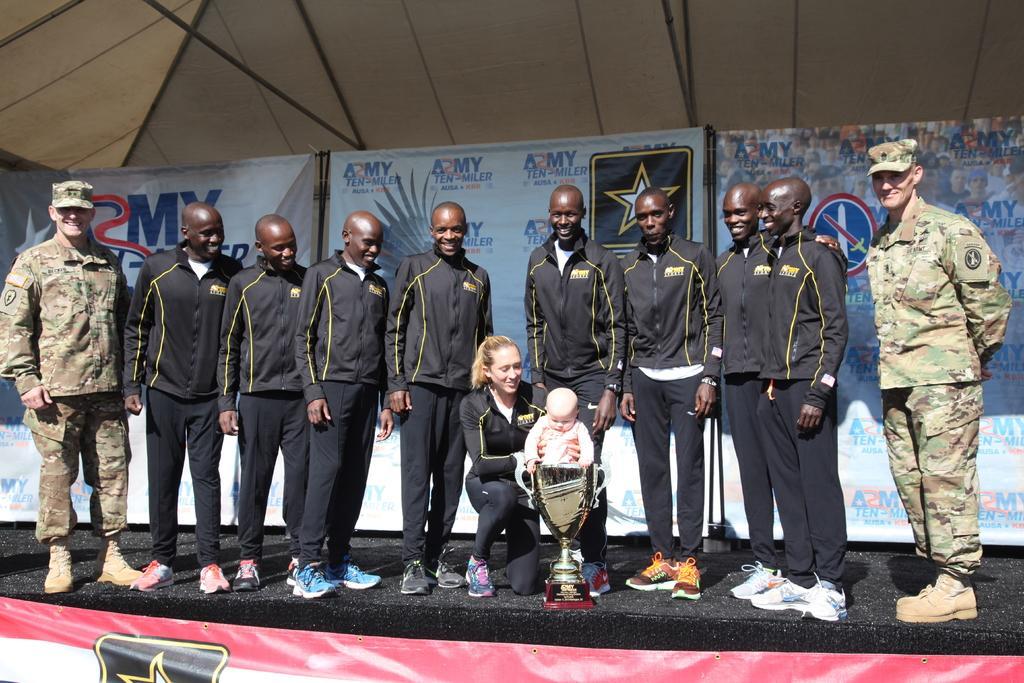Please provide a concise description of this image. In this image we can see men standing on the dais and a woman sitting on the dais by holding a baby in her hands. In the background we can see shed, advertisement and a trophy. 